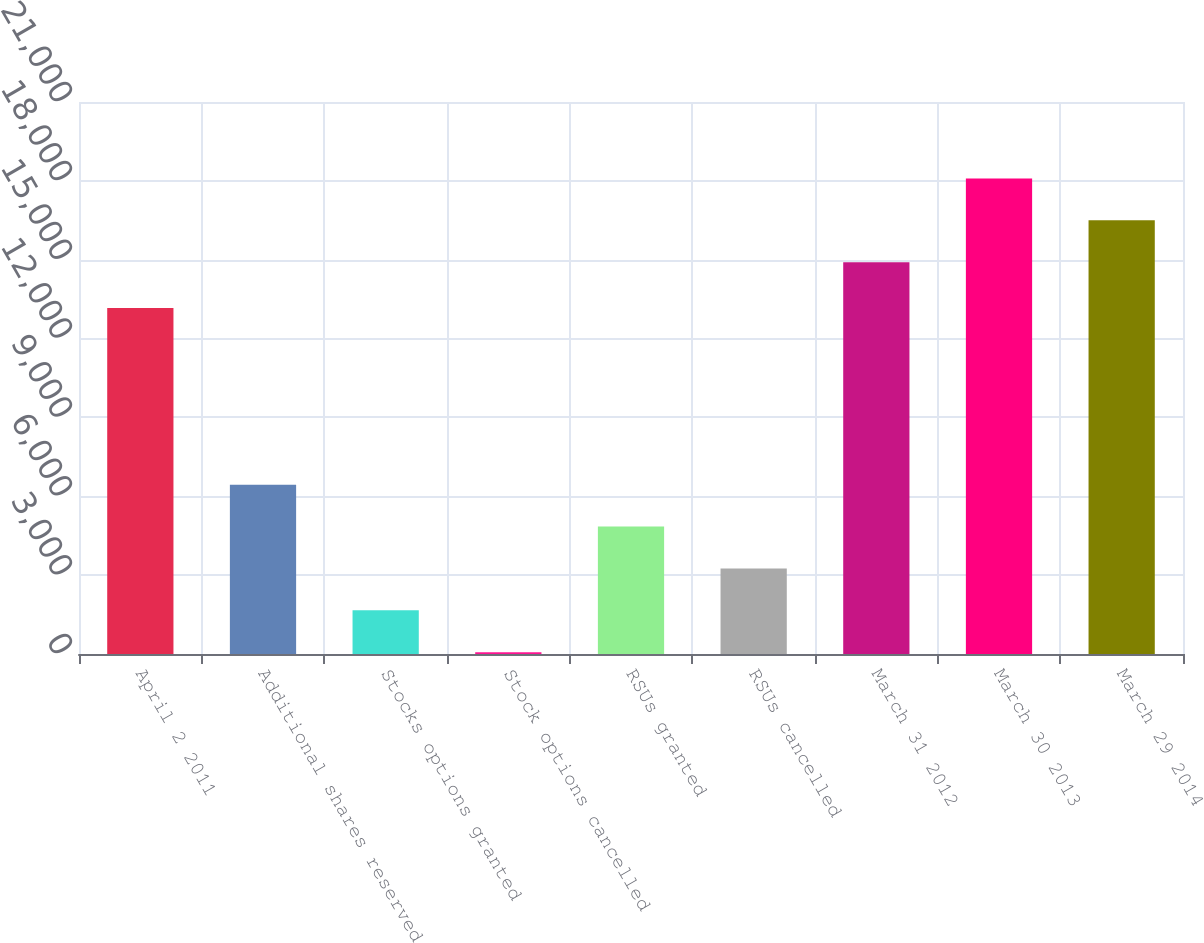Convert chart to OTSL. <chart><loc_0><loc_0><loc_500><loc_500><bar_chart><fcel>April 2 2011<fcel>Additional shares reserved<fcel>Stocks options granted<fcel>Stock options cancelled<fcel>RSUs granted<fcel>RSUs cancelled<fcel>March 31 2012<fcel>March 30 2013<fcel>March 29 2014<nl><fcel>13164<fcel>6438<fcel>1662<fcel>70<fcel>4846<fcel>3254<fcel>14908<fcel>18092<fcel>16500<nl></chart> 